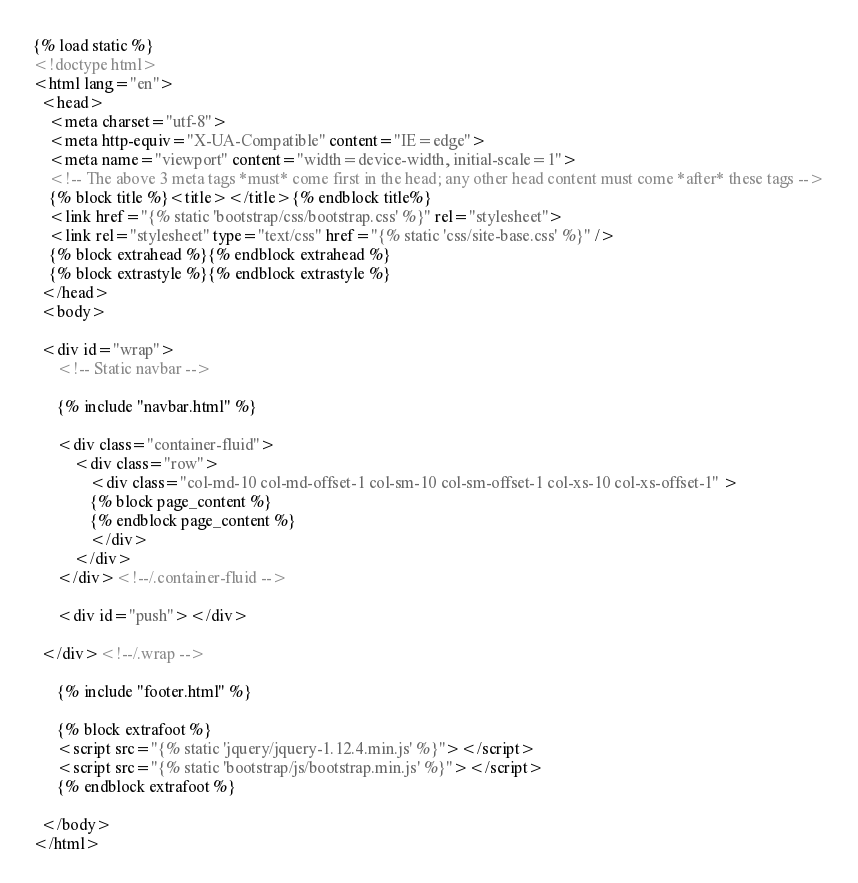<code> <loc_0><loc_0><loc_500><loc_500><_HTML_>{% load static %}
<!doctype html>
<html lang="en">
  <head>
    <meta charset="utf-8">
    <meta http-equiv="X-UA-Compatible" content="IE=edge">
    <meta name="viewport" content="width=device-width, initial-scale=1">
    <!-- The above 3 meta tags *must* come first in the head; any other head content must come *after* these tags -->
    {% block title %}<title></title>{% endblock title%}
    <link href="{% static 'bootstrap/css/bootstrap.css' %}" rel="stylesheet">
    <link rel="stylesheet" type="text/css" href="{% static 'css/site-base.css' %}" />
    {% block extrahead %}{% endblock extrahead %}
    {% block extrastyle %}{% endblock extrastyle %}
  </head>
  <body>

  <div id="wrap">
      <!-- Static navbar -->

      {% include "navbar.html" %}

      <div class="container-fluid">
          <div class="row">
              <div class="col-md-10 col-md-offset-1 col-sm-10 col-sm-offset-1 col-xs-10 col-xs-offset-1" >
              {% block page_content %}
              {% endblock page_content %}
              </div>
          </div>
      </div><!--/.container-fluid -->

      <div id="push"></div>

  </div><!--/.wrap -->

      {% include "footer.html" %}

      {% block extrafoot %}
      <script src="{% static 'jquery/jquery-1.12.4.min.js' %}"></script>
      <script src="{% static 'bootstrap/js/bootstrap.min.js' %}"></script>
      {% endblock extrafoot %}

  </body>
</html>
</code> 